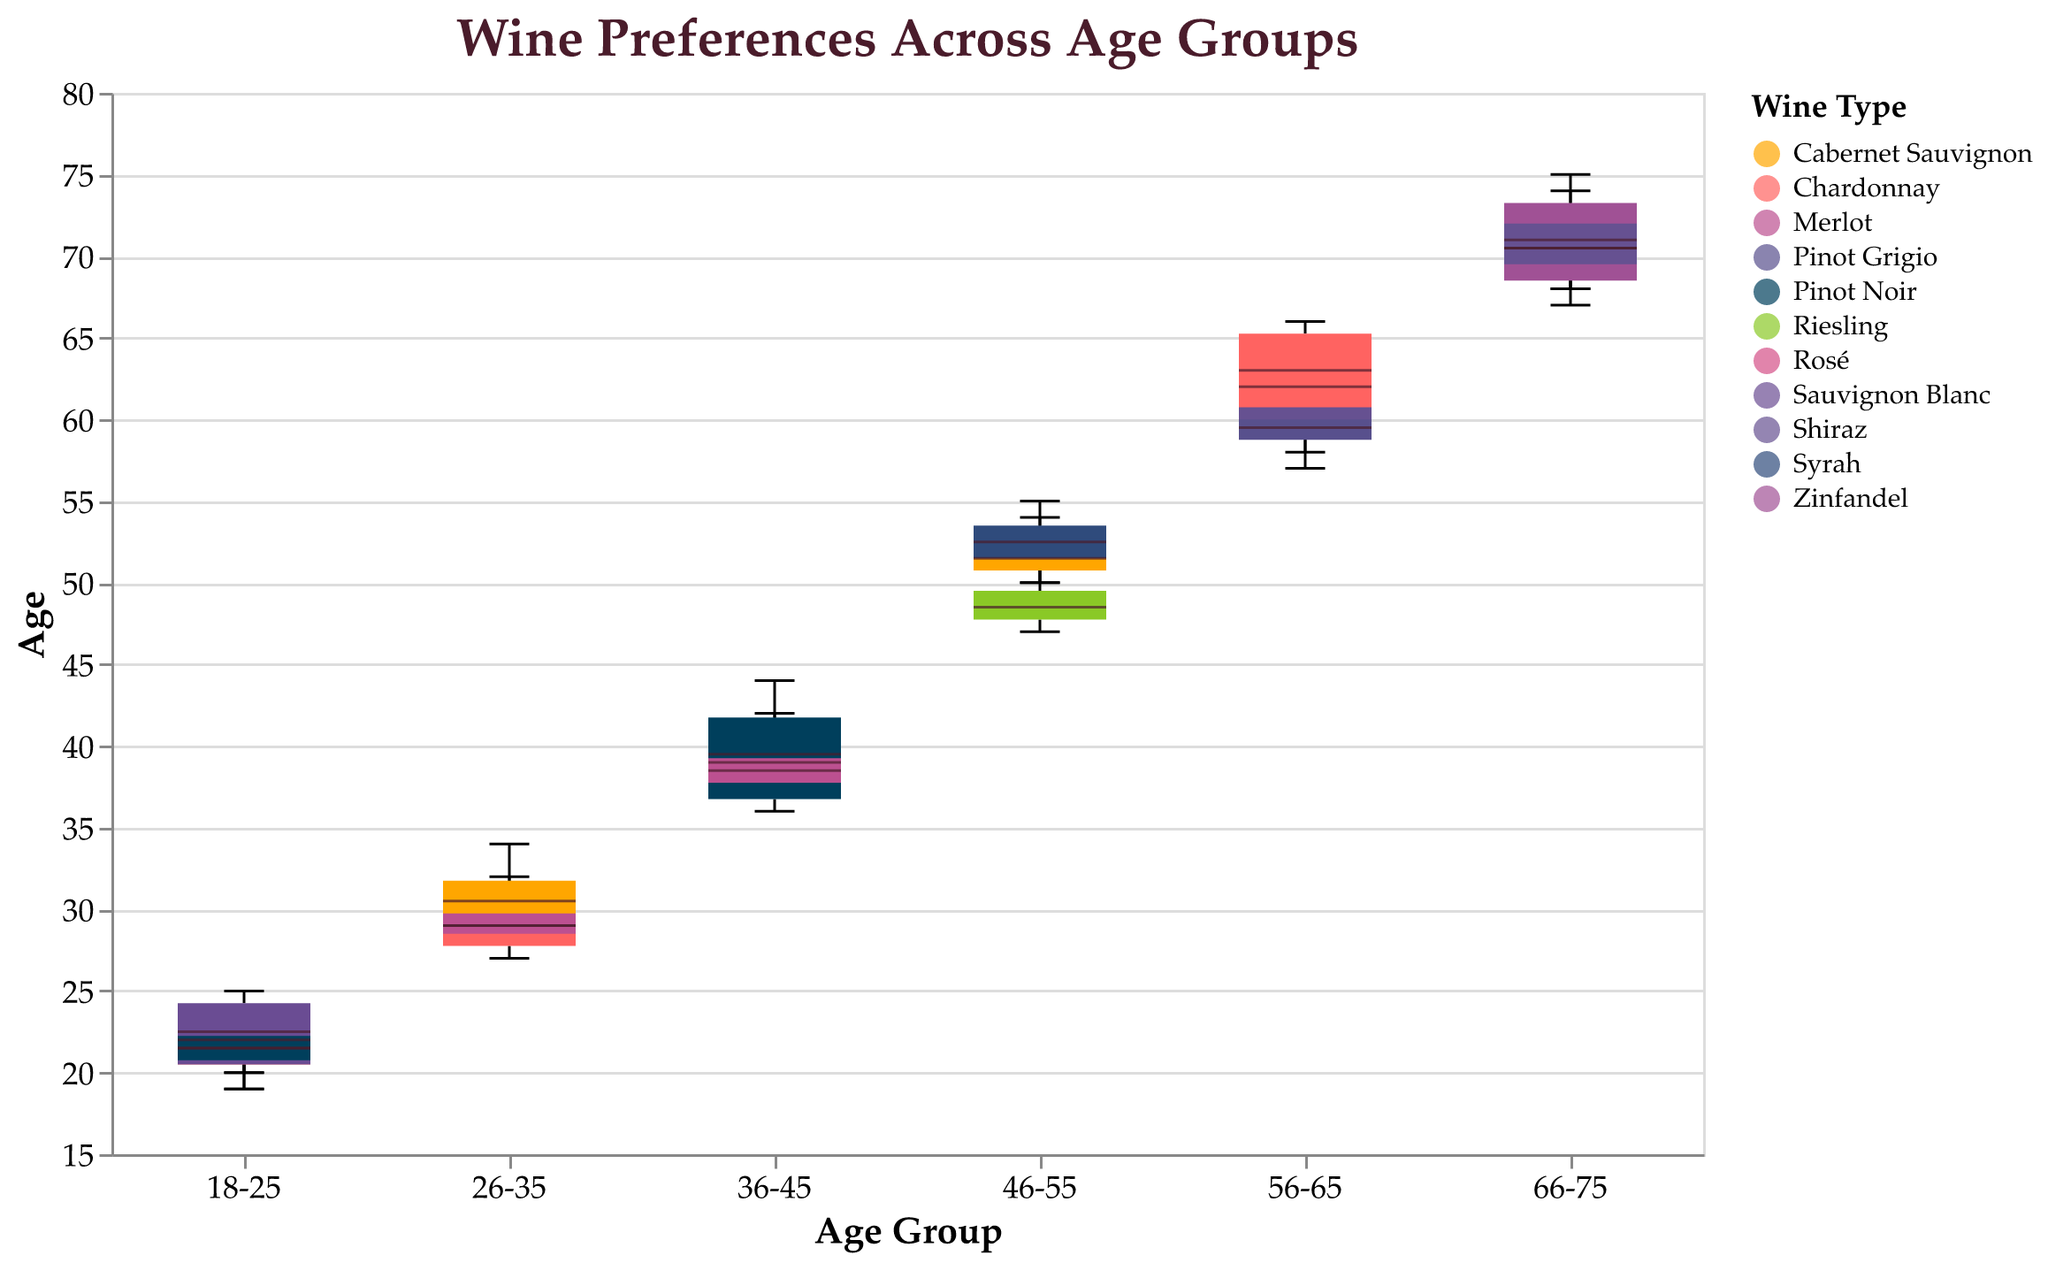What is the title of the figure? The title of the figure is clearly displayed at the top of the plot.
Answer: Wine Preferences Across Age Groups What are the age groups displayed on the x-axis? The x-axis labels list the age groups: 18-25, 26-35, 36-45, 46-55, 56-65, and 66-75.
Answer: 18-25, 26-35, 36-45, 46-55, 56-65, 66-75 Which wine type appears most frequently in the 26-35 age group? To determine the most frequent wine type, look at the color coding for the 26-35 age group and count the data points for each.
Answer: Chardonnay What is the median age for Chardonnay drinkers in the 36-45 age group? Find the box plot for Chardonnay within the 36-45 age group. The median is represented by the central line within the box.
Answer: 40 Which age group has the widest range in ages for Merlot drinkers? The range is represented by the vertical span of the boxplot. Compare the length of the Merlot boxplots across all age groups.
Answer: 66-75 How does the median age of Pinot Noir drinkers in the 18-25 group compare to those in the 36-45 group? Locate the median ages indicated by the central lines within the boxes for each age group and compare them.
Answer: 22 (18-25) vs. 39 (36-45) What is the interquartile range (IQR) for Cabernet Sauvignon drinkers in the 46-55 age group? The IQR is the difference between the upper and lower quartiles (top and bottom of the box). Identify these values from the boxplot.
Answer: 4 Which wine type has the oldest minimum age in the 56-65 age group? The minimum age (smallest whisker) for each wine type in the 56-65 age group should be considered.
Answer: Shiraz Among the 66-75 age group, which wine type has the smallest median age? Analyze the central line (median) for each wine type in the 66-75 age group and find the smallest value.
Answer: Merlot What is the age range (max-min) for Shiraz drinkers in the 46-55 age group? Look at the whisker ends to find the maximum and minimum ages and subtract the minimum from the maximum.
Answer: 5 